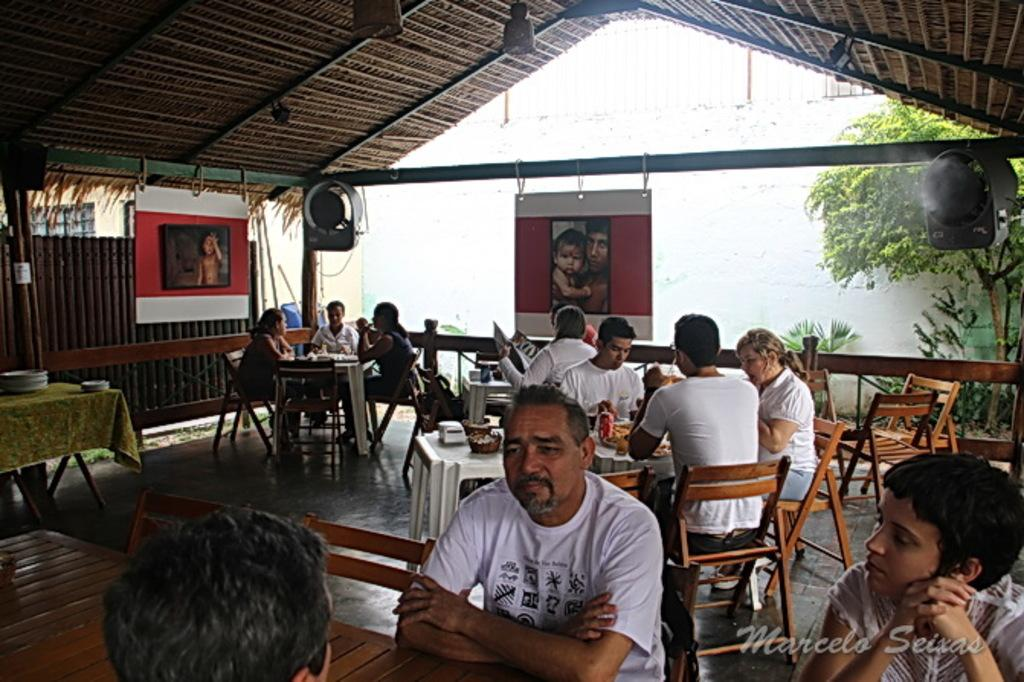How many people are in the image? There is a group of people in the image, but the exact number is not specified. What are the people doing in the image? The people are sitting on chairs in the image. Where are the chairs located in relation to the table? The chairs are in front of a table in the image. What can be found on the table? There are objects on the table in the image. What type of vegetation is visible in the image? There is a tree visible in the image. What is the board used for in the image? The purpose of the board in the image is not specified. What color is the silverware on the table in the image? There is no mention of silverware or any specific color in the image. What type of destruction can be seen in the image? There is no destruction present in the image. How does the fog affect the visibility in the image? There is no fog present in the image. 